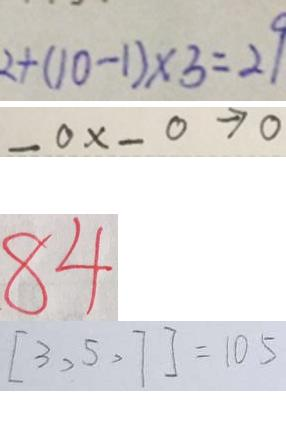<formula> <loc_0><loc_0><loc_500><loc_500>2 + ( 1 0 - 1 ) \times 3 = 2 9 
 \_ 0 \times \_ 0 \rightarrow 0 
 8 4 
 [ 3 , 5 , 7 ] = 1 0 5</formula> 